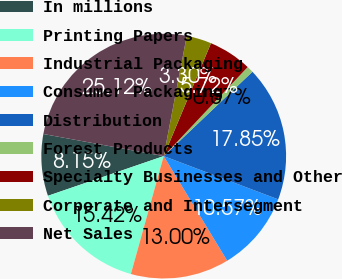<chart> <loc_0><loc_0><loc_500><loc_500><pie_chart><fcel>In millions<fcel>Printing Papers<fcel>Industrial Packaging<fcel>Consumer Packaging<fcel>Distribution<fcel>Forest Products<fcel>Specialty Businesses and Other<fcel>Corporate and Intersegment<fcel>Net Sales<nl><fcel>8.15%<fcel>15.42%<fcel>13.0%<fcel>10.57%<fcel>17.85%<fcel>0.87%<fcel>5.72%<fcel>3.3%<fcel>25.12%<nl></chart> 